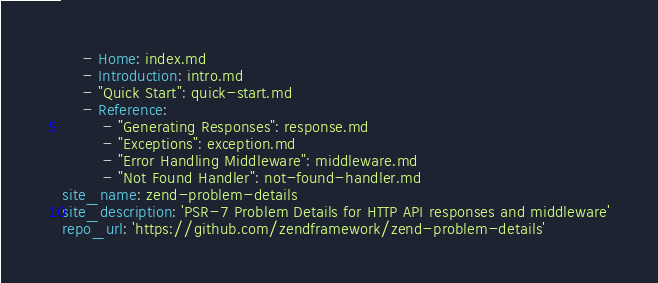Convert code to text. <code><loc_0><loc_0><loc_500><loc_500><_YAML_>    - Home: index.md
    - Introduction: intro.md
    - "Quick Start": quick-start.md
    - Reference:
        - "Generating Responses": response.md
        - "Exceptions": exception.md
        - "Error Handling Middleware": middleware.md
        - "Not Found Handler": not-found-handler.md
site_name: zend-problem-details
site_description: 'PSR-7 Problem Details for HTTP API responses and middleware'
repo_url: 'https://github.com/zendframework/zend-problem-details'
</code> 